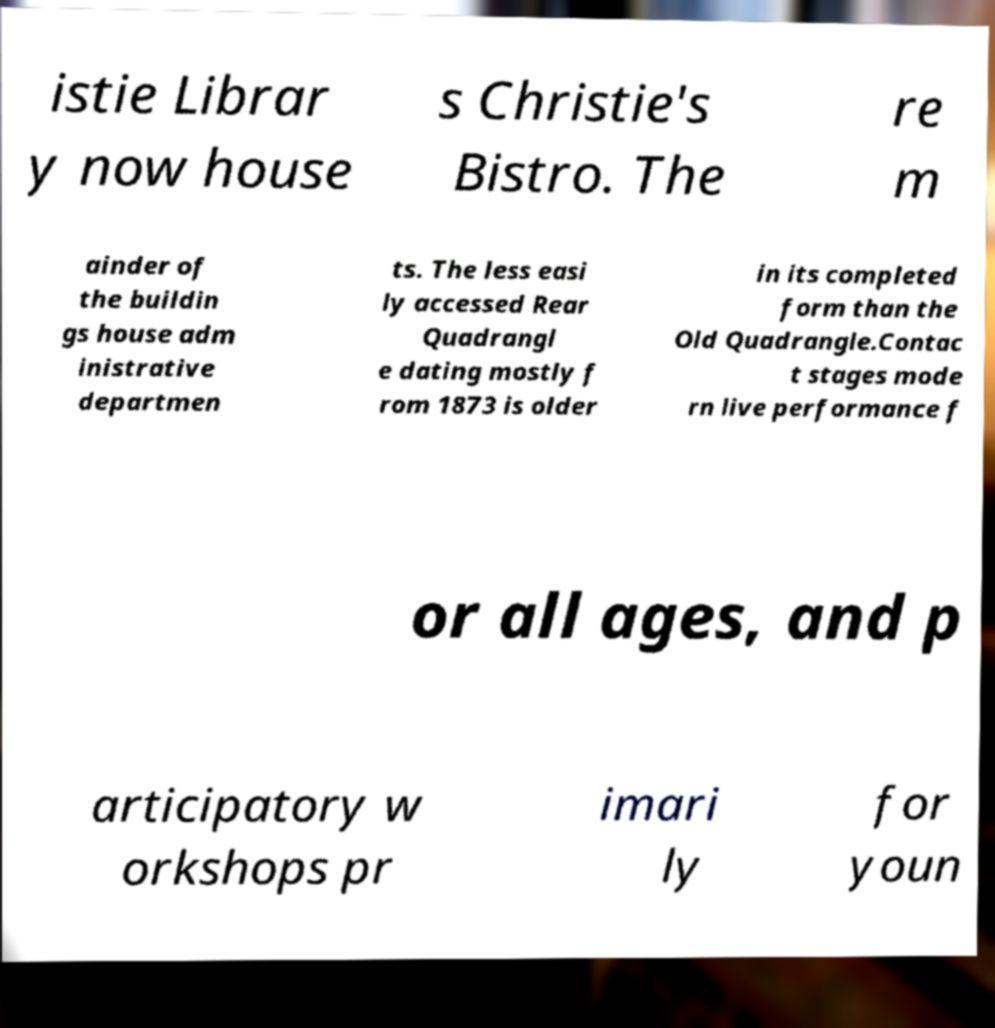What messages or text are displayed in this image? I need them in a readable, typed format. istie Librar y now house s Christie's Bistro. The re m ainder of the buildin gs house adm inistrative departmen ts. The less easi ly accessed Rear Quadrangl e dating mostly f rom 1873 is older in its completed form than the Old Quadrangle.Contac t stages mode rn live performance f or all ages, and p articipatory w orkshops pr imari ly for youn 